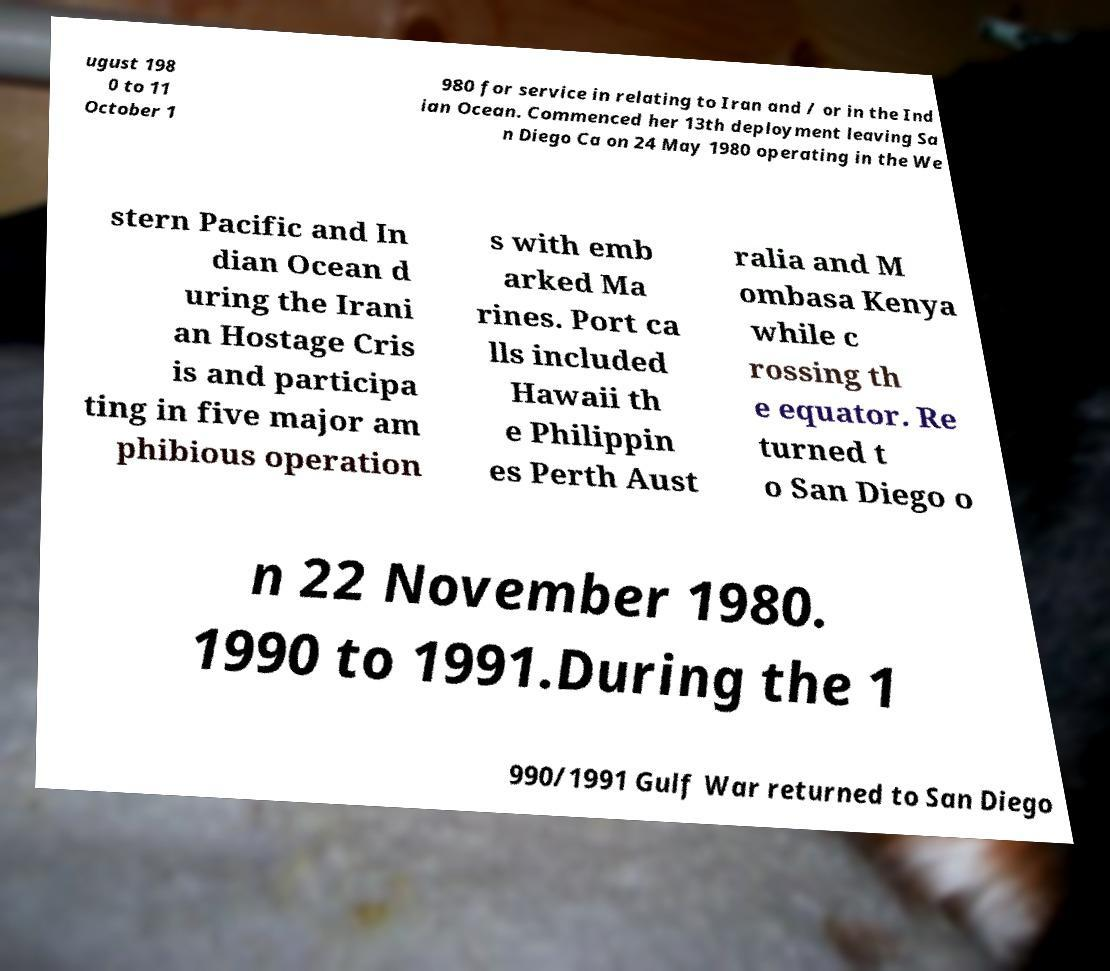What messages or text are displayed in this image? I need them in a readable, typed format. ugust 198 0 to 11 October 1 980 for service in relating to Iran and / or in the Ind ian Ocean. Commenced her 13th deployment leaving Sa n Diego Ca on 24 May 1980 operating in the We stern Pacific and In dian Ocean d uring the Irani an Hostage Cris is and participa ting in five major am phibious operation s with emb arked Ma rines. Port ca lls included Hawaii th e Philippin es Perth Aust ralia and M ombasa Kenya while c rossing th e equator. Re turned t o San Diego o n 22 November 1980. 1990 to 1991.During the 1 990/1991 Gulf War returned to San Diego 